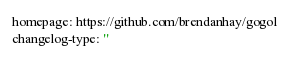<code> <loc_0><loc_0><loc_500><loc_500><_YAML_>homepage: https://github.com/brendanhay/gogol
changelog-type: ''</code> 